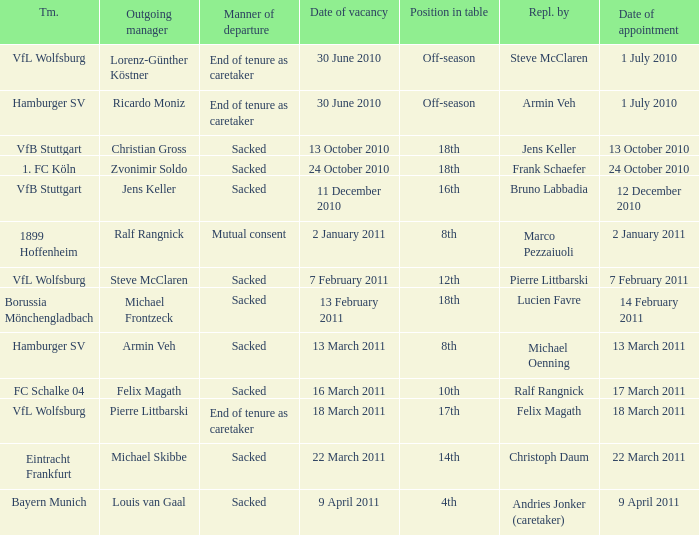When 1. fc köln is the team what is the date of appointment? 24 October 2010. 